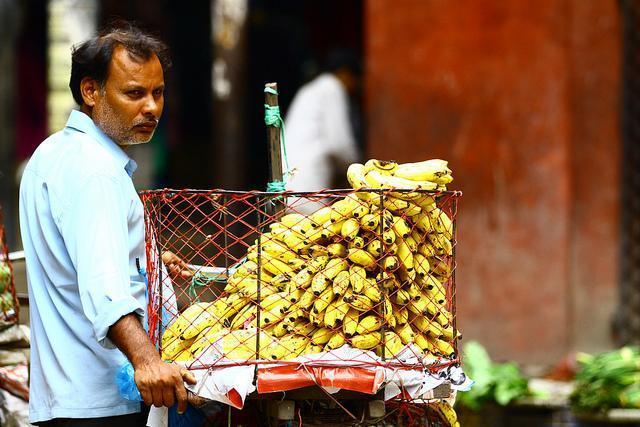How many different fruits are there?
Give a very brief answer. 1. How many people can you see?
Give a very brief answer. 2. 